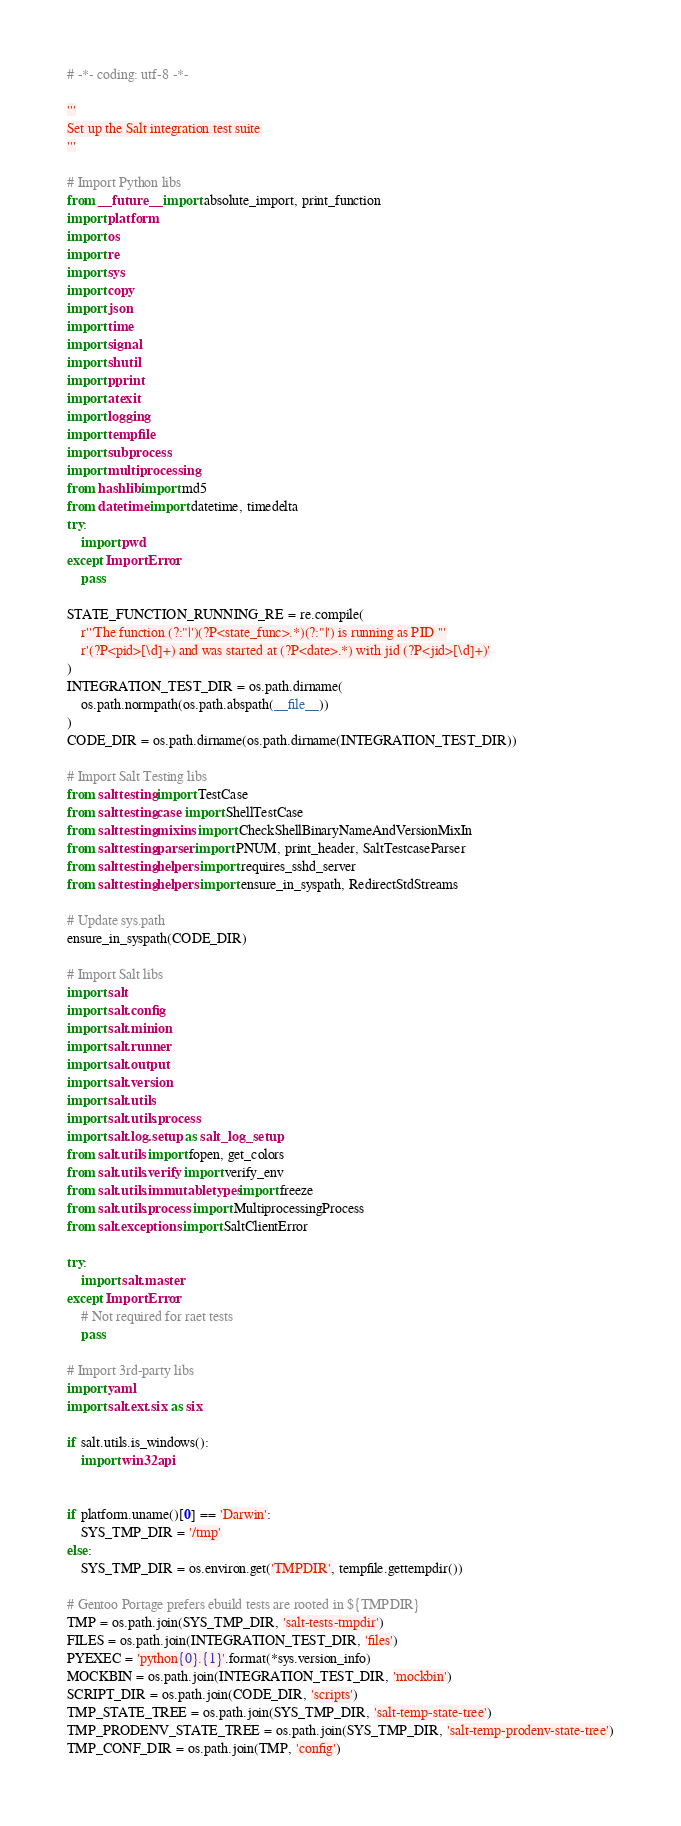Convert code to text. <code><loc_0><loc_0><loc_500><loc_500><_Python_># -*- coding: utf-8 -*-

'''
Set up the Salt integration test suite
'''

# Import Python libs
from __future__ import absolute_import, print_function
import platform
import os
import re
import sys
import copy
import json
import time
import signal
import shutil
import pprint
import atexit
import logging
import tempfile
import subprocess
import multiprocessing
from hashlib import md5
from datetime import datetime, timedelta
try:
    import pwd
except ImportError:
    pass

STATE_FUNCTION_RUNNING_RE = re.compile(
    r'''The function (?:"|')(?P<state_func>.*)(?:"|') is running as PID '''
    r'(?P<pid>[\d]+) and was started at (?P<date>.*) with jid (?P<jid>[\d]+)'
)
INTEGRATION_TEST_DIR = os.path.dirname(
    os.path.normpath(os.path.abspath(__file__))
)
CODE_DIR = os.path.dirname(os.path.dirname(INTEGRATION_TEST_DIR))

# Import Salt Testing libs
from salttesting import TestCase
from salttesting.case import ShellTestCase
from salttesting.mixins import CheckShellBinaryNameAndVersionMixIn
from salttesting.parser import PNUM, print_header, SaltTestcaseParser
from salttesting.helpers import requires_sshd_server
from salttesting.helpers import ensure_in_syspath, RedirectStdStreams

# Update sys.path
ensure_in_syspath(CODE_DIR)

# Import Salt libs
import salt
import salt.config
import salt.minion
import salt.runner
import salt.output
import salt.version
import salt.utils
import salt.utils.process
import salt.log.setup as salt_log_setup
from salt.utils import fopen, get_colors
from salt.utils.verify import verify_env
from salt.utils.immutabletypes import freeze
from salt.utils.process import MultiprocessingProcess
from salt.exceptions import SaltClientError

try:
    import salt.master
except ImportError:
    # Not required for raet tests
    pass

# Import 3rd-party libs
import yaml
import salt.ext.six as six

if salt.utils.is_windows():
    import win32api


if platform.uname()[0] == 'Darwin':
    SYS_TMP_DIR = '/tmp'
else:
    SYS_TMP_DIR = os.environ.get('TMPDIR', tempfile.gettempdir())

# Gentoo Portage prefers ebuild tests are rooted in ${TMPDIR}
TMP = os.path.join(SYS_TMP_DIR, 'salt-tests-tmpdir')
FILES = os.path.join(INTEGRATION_TEST_DIR, 'files')
PYEXEC = 'python{0}.{1}'.format(*sys.version_info)
MOCKBIN = os.path.join(INTEGRATION_TEST_DIR, 'mockbin')
SCRIPT_DIR = os.path.join(CODE_DIR, 'scripts')
TMP_STATE_TREE = os.path.join(SYS_TMP_DIR, 'salt-temp-state-tree')
TMP_PRODENV_STATE_TREE = os.path.join(SYS_TMP_DIR, 'salt-temp-prodenv-state-tree')
TMP_CONF_DIR = os.path.join(TMP, 'config')</code> 